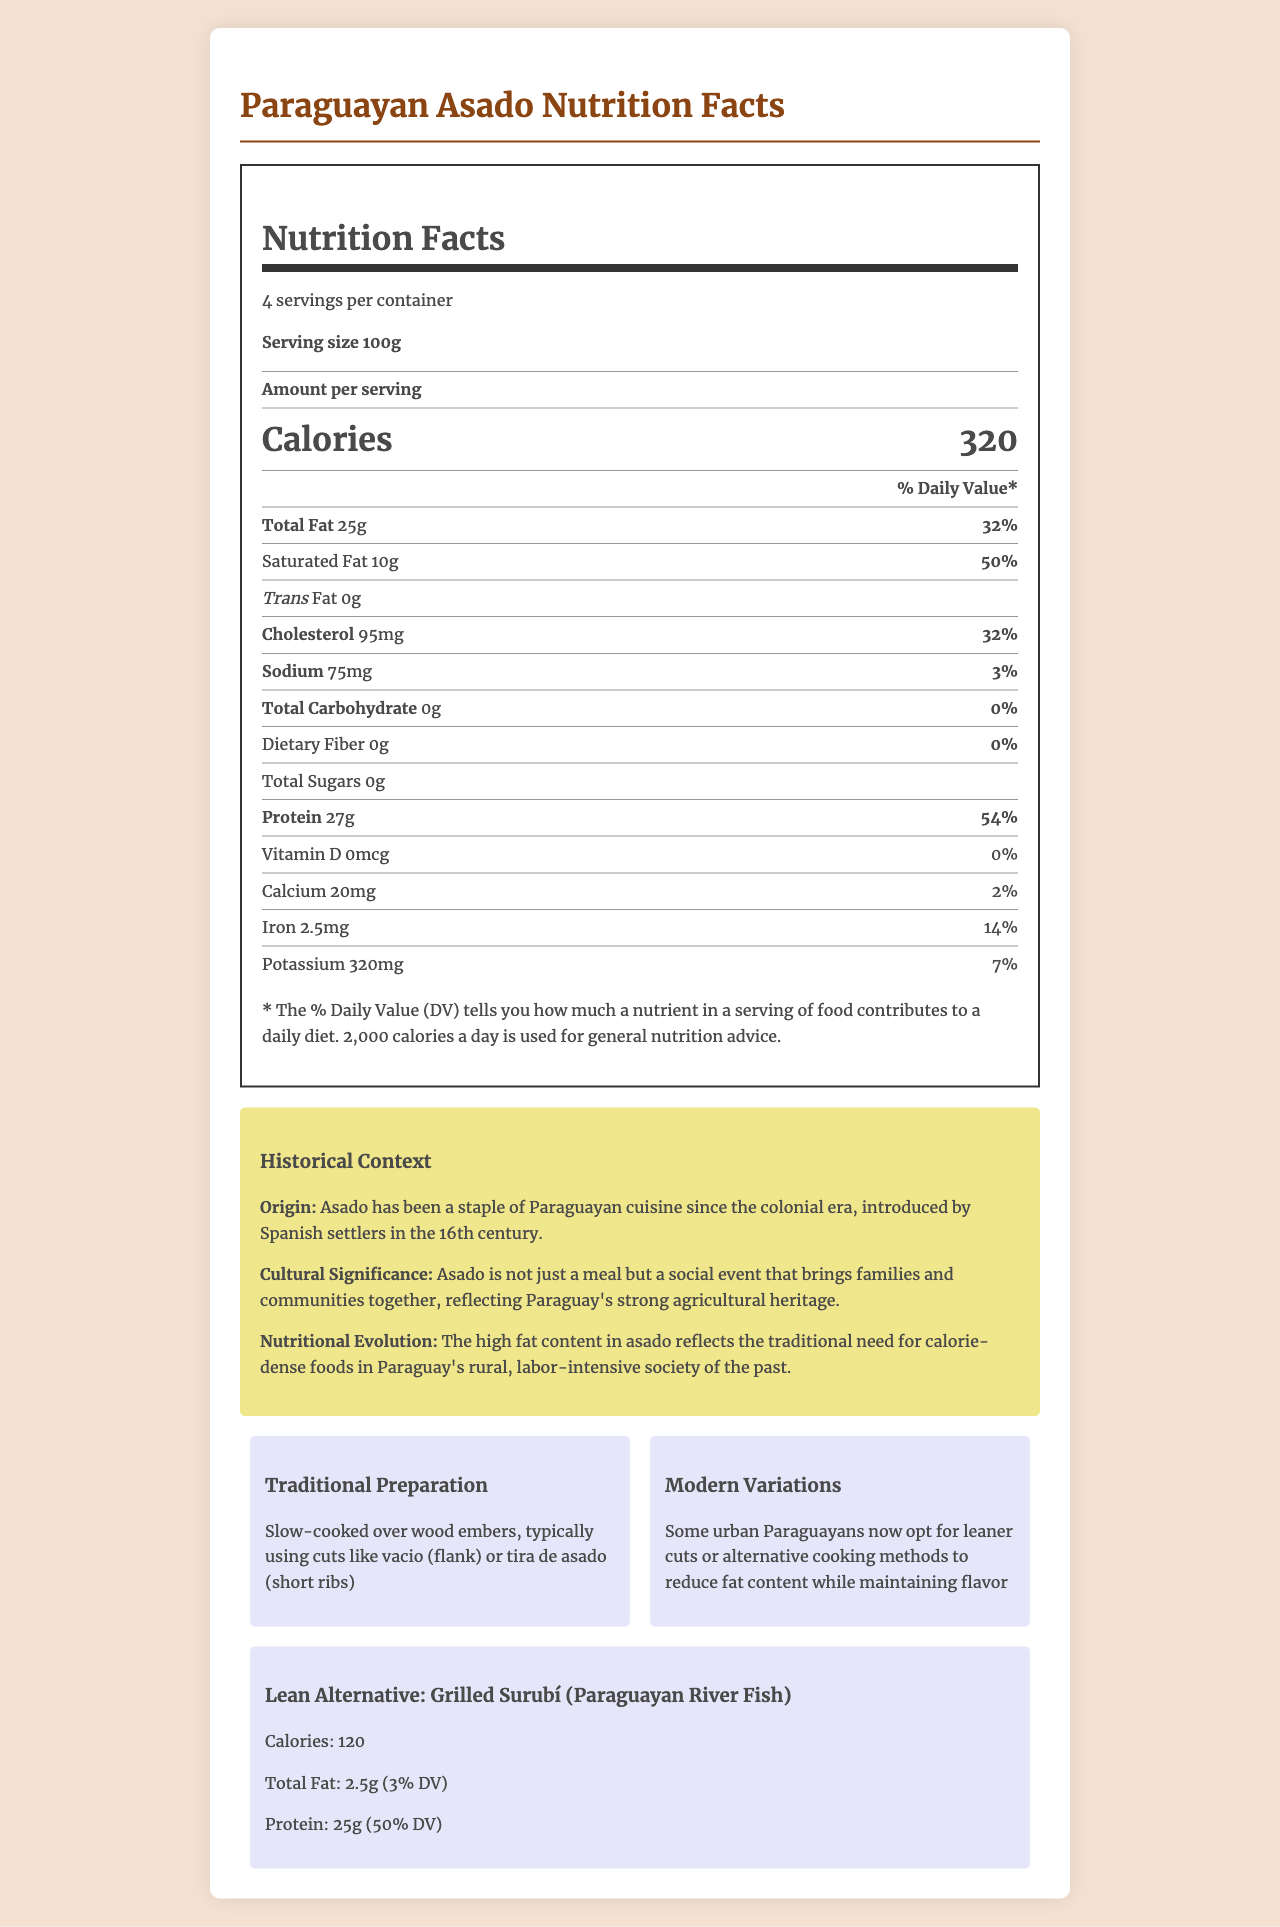what is the serving size of Paraguayan Asado? The serving size of Paraguayan Asado is mentioned as "100g" in the document.
Answer: 100g how many servings are there per container of Paraguayan Asado? The document states that there are 4 servings per container.
Answer: 4 what is the saturated fat content per serving in grams? The saturated fat content is listed as 10g per serving in the document.
Answer: 10g how much vitamin D is present in a serving of Paraguayan Asado? The document shows that there is 0mcg of vitamin D per serving.
Answer: 0mcg what is the calorie content of 100g of Grilled Surubí? The document specifies that there are 120 calories per 100g serving of Grilled Surubí.
Answer: 120 calories how does the total fat content of Paraguayan Asado compare to Grilled Surubí? A. More in Asado B. More in Grilled Surubí C. The same Paraguayan Asado has 25g of total fat per serving, while Grilled Surubí has only 2.5g.
Answer: A. More in Asado which nutrient in Paraguayan Asado contributes 54% of the Daily Value? A. Total Fat B. Protein C. Cholesterol The document states that the protein content in Paraguayan Asado is 27g, which is 54% of the Daily Value.
Answer: B. Protein is Paraguayan Asado high in carbohydrates? The document indicates that Paraguayan Asado has 0g of carbohydrates, making it low in carbs.
Answer: No is it true that Paraguayan Asado has the same amount of cholesterol as Grilled Surubí? Paraguayan Asado has 95mg of cholesterol, while the cholesterol content for Grilled Surubí is not specified. Therefore, it cannot be assumed to be the same.
Answer: No describe the main idea of the document. The document includes detailed nutritional information for Paraguayan Asado, compares it to a lean meat alternative, and provides historical and cultural insights as well as preparation methods and regional comparisons.
Answer: The document provides a detailed nutritional analysis of Paraguayan Asado, including its caloric, fat, and protein content, and compares it with a lean meat alternative, Grilled Surubí. It also discusses the historical context, traditional preparation methods, and provides regional comparisons. what is the difference in protein content between Paraguayan Asado and Grilled Surubí? Paraguayan Asado contains 27g of protein per serving, whereas Grilled Surubí contains 25g, resulting in a difference of 2g.
Answer: 2g can we determine the exact amount of cholesterol in Grilled Surubí based on the document? The exact amount of cholesterol in Grilled Surubí is not mentioned in the document. Only the cholesterol content for Paraguayan Asado is provided.
Answer: Cannot be determined how does Paraguayan Asado's sodium content compare to the daily value percentage? The document states that the sodium content in Paraguayan Asado is 75mg, which is 3% of the daily value.
Answer: 3% which regional comparison mentions the use of different cattle breeds and cuts? The document notes that Brazilian churrasco tends to be slightly leaner due to different cattle breeds and cuts used.
Answer: Brazil what is the daily value percentage of iron in Paraguayan Asado? The document shows that the iron content in Paraguayan Asado is 2.5mg, which is 14% of the daily value.
Answer: 14% 